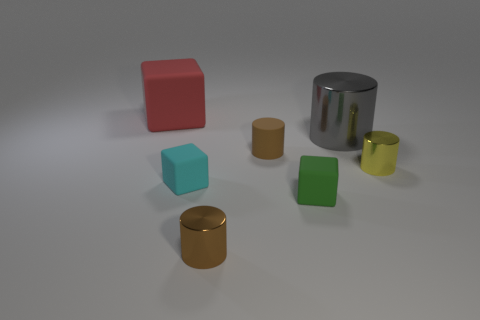There is another cylinder that is the same color as the rubber cylinder; what is its material?
Keep it short and to the point. Metal. Are there any other things that are the same size as the yellow shiny cylinder?
Make the answer very short. Yes. There is a shiny thing on the left side of the small green block; is its color the same as the small cylinder right of the big gray metallic cylinder?
Your answer should be very brief. No. There is a gray thing; what shape is it?
Make the answer very short. Cylinder. Are there more yellow things in front of the cyan rubber block than large matte things?
Give a very brief answer. No. What is the shape of the shiny thing left of the gray thing?
Your response must be concise. Cylinder. What number of other things are there of the same shape as the tiny yellow metallic thing?
Provide a succinct answer. 3. Is the material of the large cube behind the gray metal cylinder the same as the small yellow cylinder?
Your response must be concise. No. Is the number of gray metal cylinders that are to the left of the yellow shiny thing the same as the number of brown matte objects that are right of the tiny green cube?
Your response must be concise. No. What is the size of the brown object that is to the right of the small brown metal thing?
Your response must be concise. Small. 